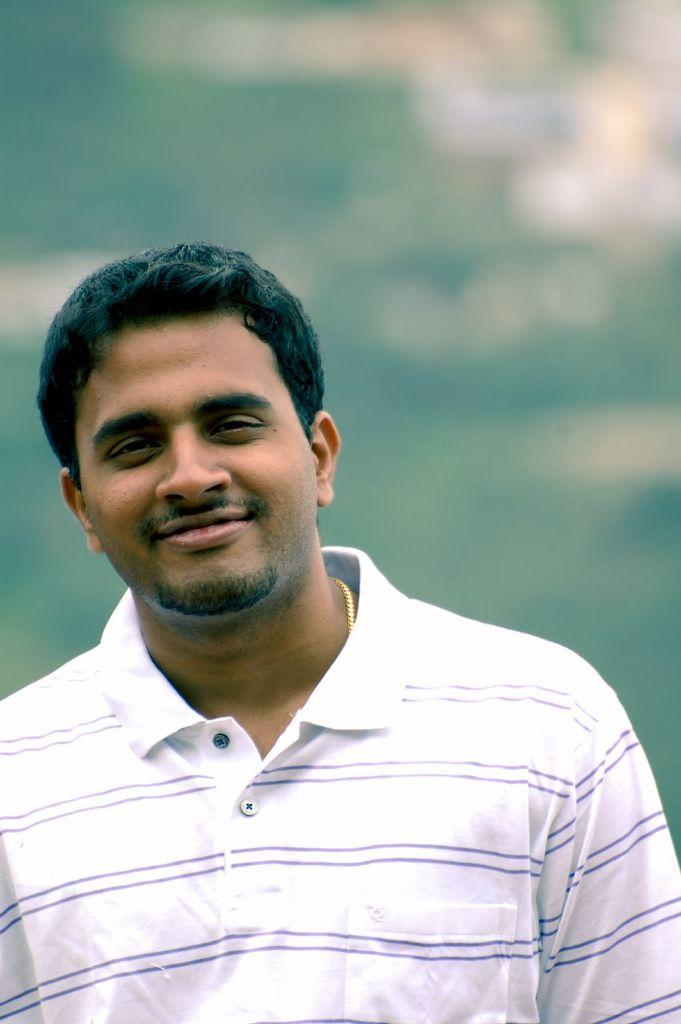What is the main subject of the image? There is a person in the image. What is the person wearing? The person is wearing a white and blue color dress. Can you describe the background of the image? The background of the image is blurred. What historical event is depicted in the image? There is no historical event depicted in the image; it features a person wearing a white and blue color dress with a blurred background. Can you see any blood on the person's dress in the image? There is no blood visible on the person's dress in the image. 